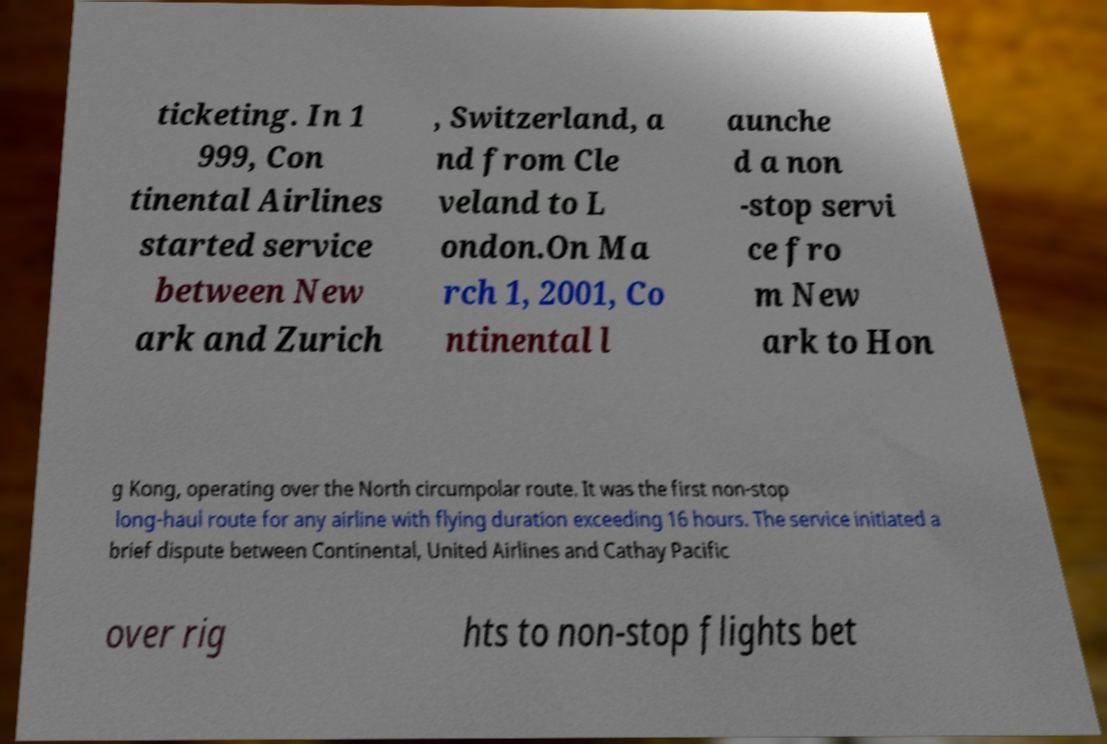What messages or text are displayed in this image? I need them in a readable, typed format. ticketing. In 1 999, Con tinental Airlines started service between New ark and Zurich , Switzerland, a nd from Cle veland to L ondon.On Ma rch 1, 2001, Co ntinental l aunche d a non -stop servi ce fro m New ark to Hon g Kong, operating over the North circumpolar route. It was the first non-stop long-haul route for any airline with flying duration exceeding 16 hours. The service initiated a brief dispute between Continental, United Airlines and Cathay Pacific over rig hts to non-stop flights bet 